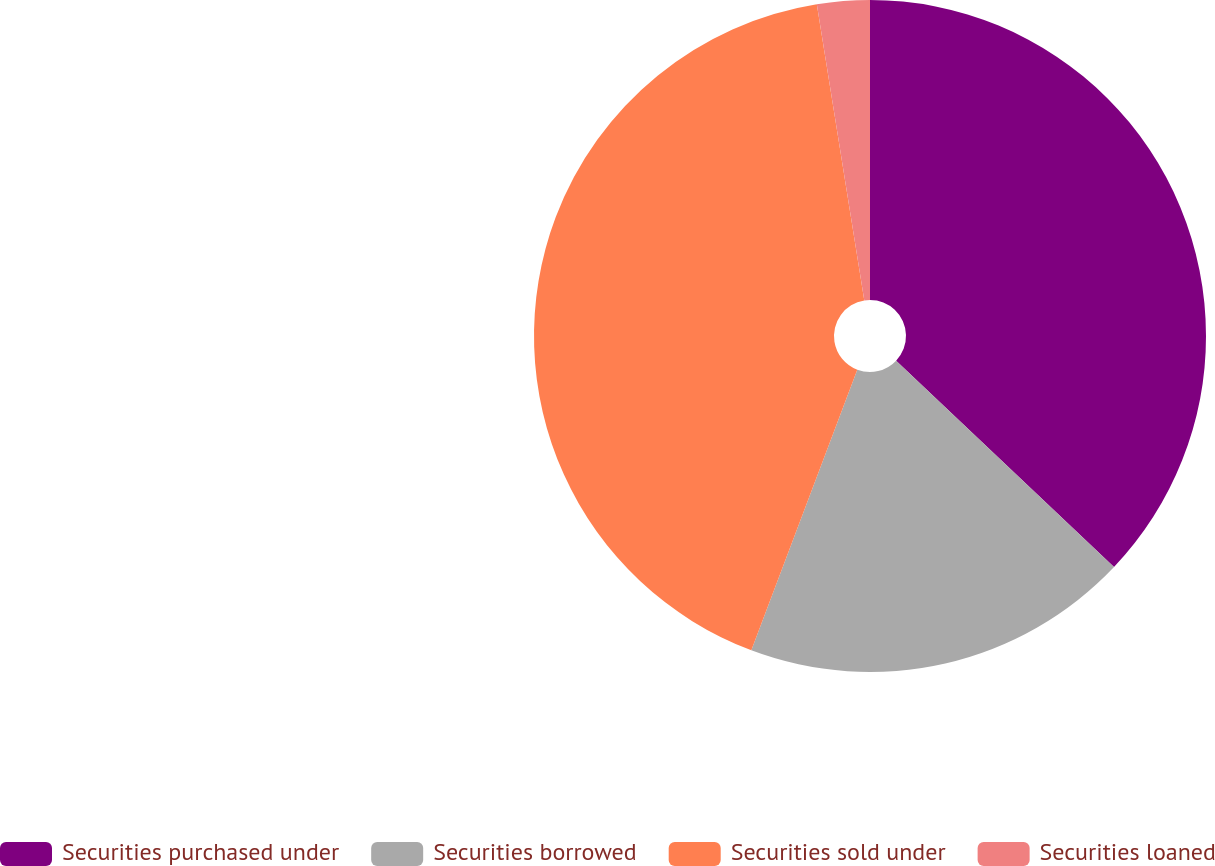Convert chart to OTSL. <chart><loc_0><loc_0><loc_500><loc_500><pie_chart><fcel>Securities purchased under<fcel>Securities borrowed<fcel>Securities sold under<fcel>Securities loaned<nl><fcel>37.06%<fcel>18.68%<fcel>41.72%<fcel>2.53%<nl></chart> 